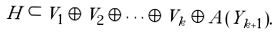Convert formula to latex. <formula><loc_0><loc_0><loc_500><loc_500>H \subset V _ { 1 } \oplus V _ { 2 } \oplus \dots \oplus V _ { k } \oplus A ( Y _ { k + 1 } ) .</formula> 